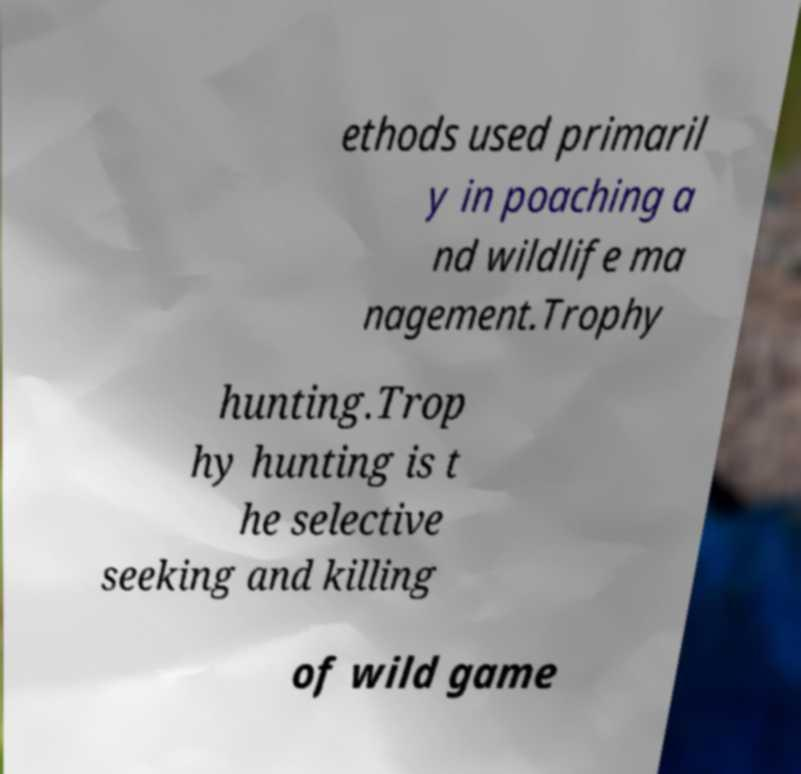I need the written content from this picture converted into text. Can you do that? ethods used primaril y in poaching a nd wildlife ma nagement.Trophy hunting.Trop hy hunting is t he selective seeking and killing of wild game 